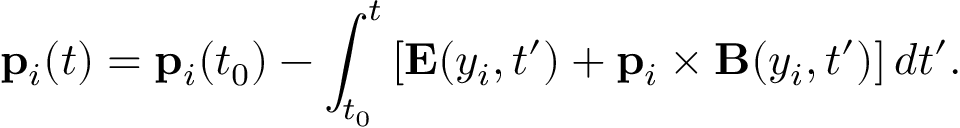<formula> <loc_0><loc_0><loc_500><loc_500>p _ { i } ( t ) = p _ { i } ( t _ { 0 } ) - \int _ { t _ { 0 } } ^ { t } \left [ E ( y _ { i } , t ^ { \prime } ) + p _ { i } \times B ( y _ { i } , t ^ { \prime } ) \right ] d t ^ { \prime } .</formula> 